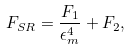<formula> <loc_0><loc_0><loc_500><loc_500>F _ { S R } = \frac { F _ { 1 } } { \epsilon ^ { 4 } _ { m } } + F _ { 2 } ,</formula> 